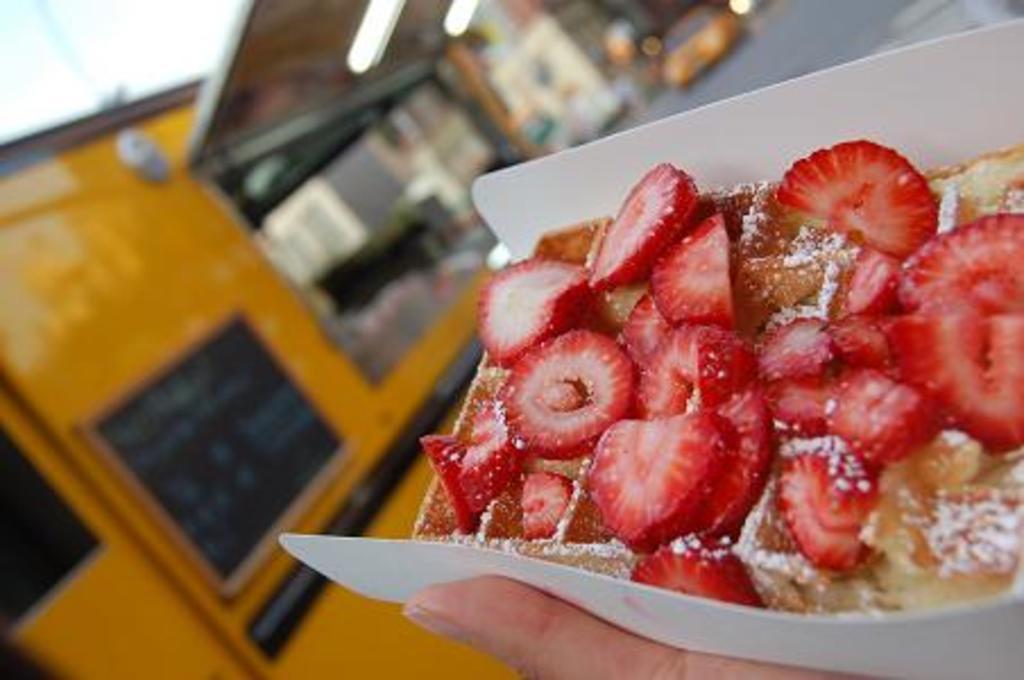In one or two sentences, can you explain what this image depicts? In this image I can see food which is in brown and red color in the plate and the plate is in white color. At left I can see wooden wall which is in brown color and the sky is in white color. 